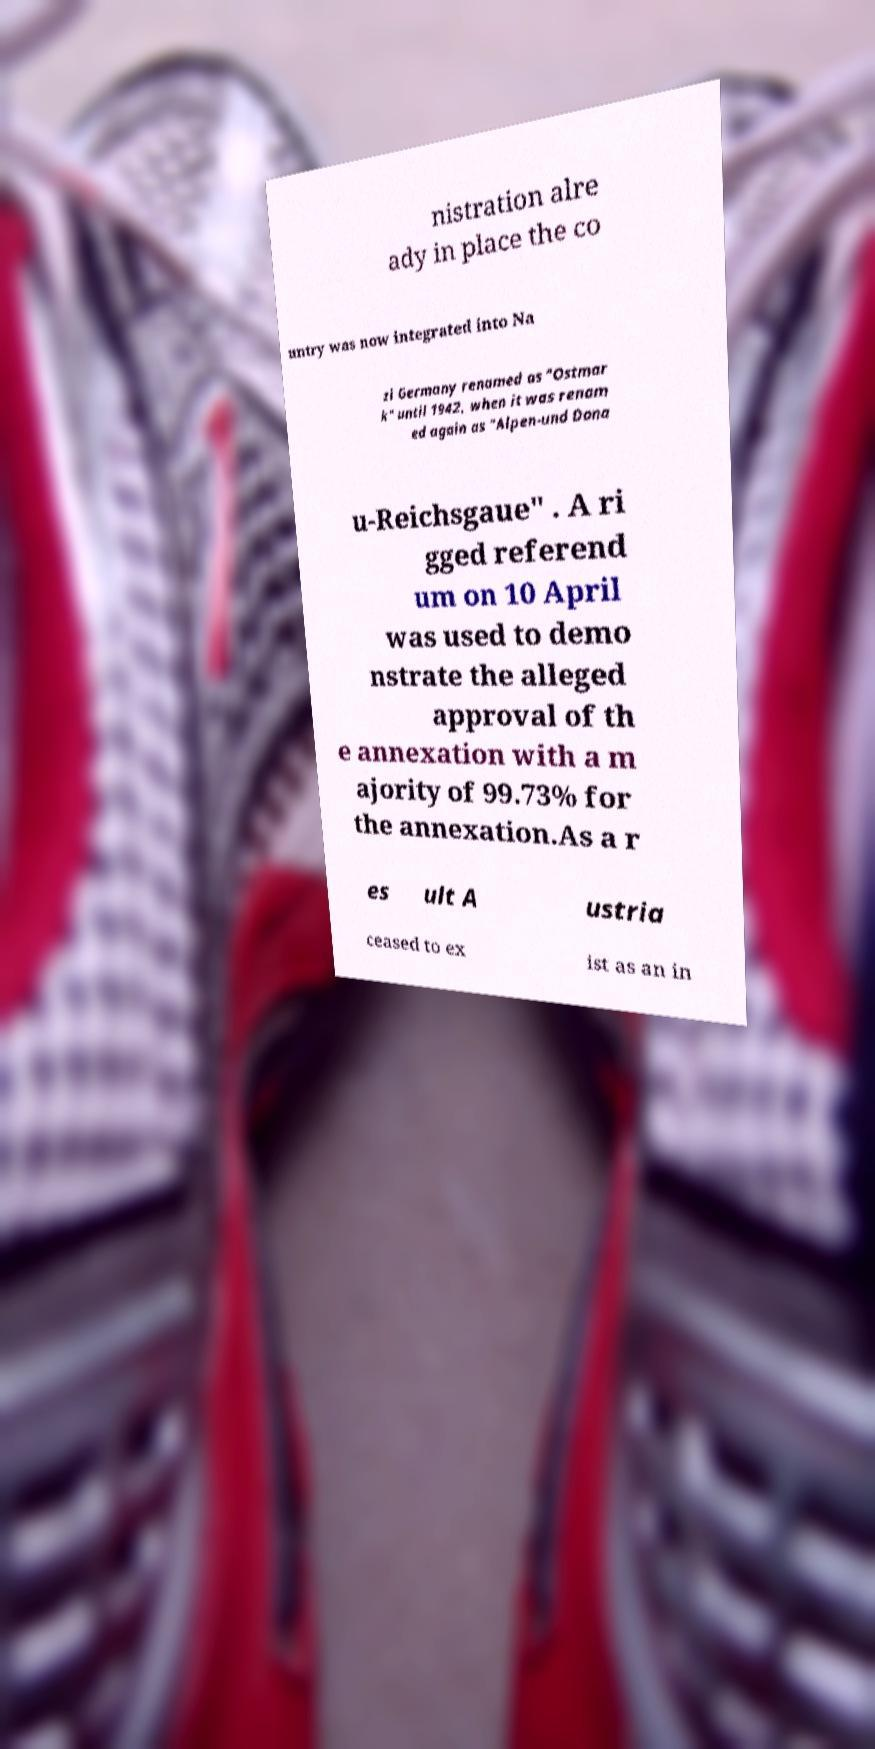There's text embedded in this image that I need extracted. Can you transcribe it verbatim? nistration alre ady in place the co untry was now integrated into Na zi Germany renamed as "Ostmar k" until 1942, when it was renam ed again as "Alpen-und Dona u-Reichsgaue" . A ri gged referend um on 10 April was used to demo nstrate the alleged approval of th e annexation with a m ajority of 99.73% for the annexation.As a r es ult A ustria ceased to ex ist as an in 